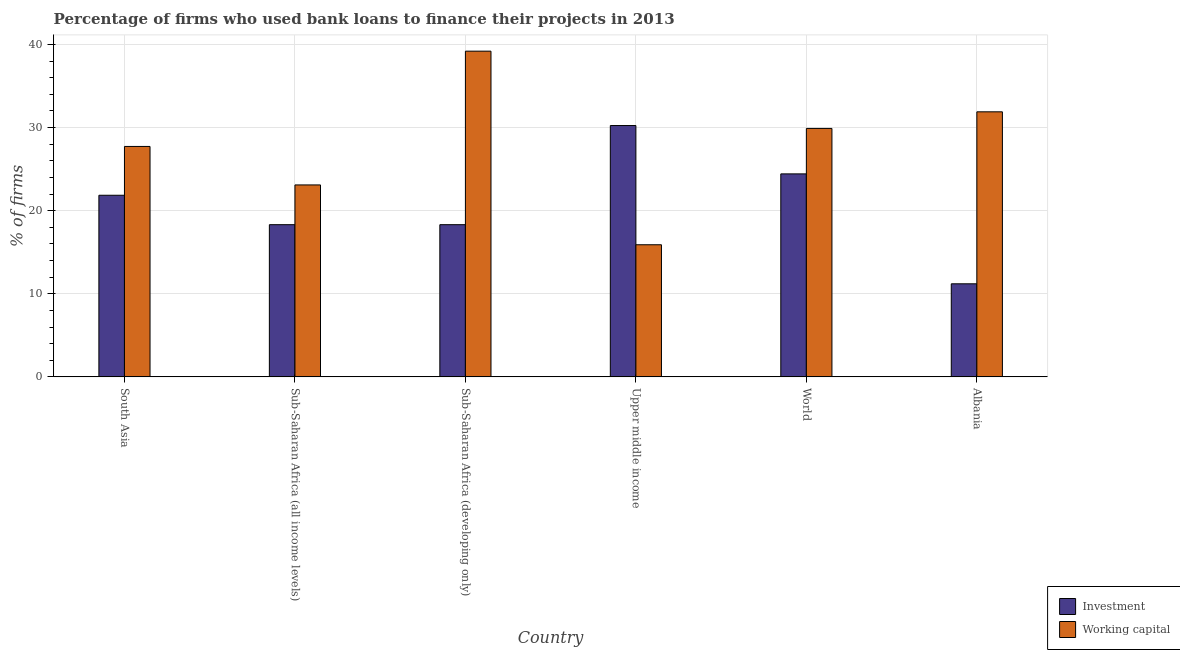Are the number of bars per tick equal to the number of legend labels?
Your answer should be very brief. Yes. Are the number of bars on each tick of the X-axis equal?
Offer a terse response. Yes. How many bars are there on the 6th tick from the left?
Offer a very short reply. 2. How many bars are there on the 2nd tick from the right?
Give a very brief answer. 2. What is the label of the 6th group of bars from the left?
Make the answer very short. Albania. What is the percentage of firms using banks to finance investment in Sub-Saharan Africa (all income levels)?
Offer a terse response. 18.32. Across all countries, what is the maximum percentage of firms using banks to finance working capital?
Provide a short and direct response. 39.2. In which country was the percentage of firms using banks to finance working capital maximum?
Make the answer very short. Sub-Saharan Africa (developing only). In which country was the percentage of firms using banks to finance working capital minimum?
Provide a succinct answer. Upper middle income. What is the total percentage of firms using banks to finance working capital in the graph?
Your answer should be compact. 167.73. What is the difference between the percentage of firms using banks to finance working capital in Albania and that in World?
Give a very brief answer. 2. What is the difference between the percentage of firms using banks to finance working capital in Upper middle income and the percentage of firms using banks to finance investment in World?
Provide a short and direct response. -8.53. What is the average percentage of firms using banks to finance working capital per country?
Your answer should be compact. 27.96. What is the difference between the percentage of firms using banks to finance investment and percentage of firms using banks to finance working capital in Upper middle income?
Your response must be concise. 14.35. What is the ratio of the percentage of firms using banks to finance working capital in Albania to that in Upper middle income?
Your response must be concise. 2.01. Is the difference between the percentage of firms using banks to finance working capital in Sub-Saharan Africa (developing only) and Upper middle income greater than the difference between the percentage of firms using banks to finance investment in Sub-Saharan Africa (developing only) and Upper middle income?
Offer a terse response. Yes. What is the difference between the highest and the second highest percentage of firms using banks to finance working capital?
Ensure brevity in your answer.  7.3. What is the difference between the highest and the lowest percentage of firms using banks to finance working capital?
Keep it short and to the point. 23.3. What does the 1st bar from the left in World represents?
Give a very brief answer. Investment. What does the 1st bar from the right in Sub-Saharan Africa (developing only) represents?
Ensure brevity in your answer.  Working capital. How many bars are there?
Your response must be concise. 12. How many countries are there in the graph?
Give a very brief answer. 6. What is the difference between two consecutive major ticks on the Y-axis?
Offer a terse response. 10. Are the values on the major ticks of Y-axis written in scientific E-notation?
Your answer should be very brief. No. Does the graph contain any zero values?
Offer a terse response. No. Where does the legend appear in the graph?
Offer a terse response. Bottom right. How many legend labels are there?
Keep it short and to the point. 2. How are the legend labels stacked?
Provide a short and direct response. Vertical. What is the title of the graph?
Your answer should be compact. Percentage of firms who used bank loans to finance their projects in 2013. Does "Female labourers" appear as one of the legend labels in the graph?
Offer a very short reply. No. What is the label or title of the X-axis?
Offer a terse response. Country. What is the label or title of the Y-axis?
Your response must be concise. % of firms. What is the % of firms in Investment in South Asia?
Provide a short and direct response. 21.86. What is the % of firms of Working capital in South Asia?
Provide a succinct answer. 27.73. What is the % of firms in Investment in Sub-Saharan Africa (all income levels)?
Provide a succinct answer. 18.32. What is the % of firms in Working capital in Sub-Saharan Africa (all income levels)?
Your answer should be compact. 23.1. What is the % of firms of Investment in Sub-Saharan Africa (developing only)?
Your answer should be very brief. 18.32. What is the % of firms in Working capital in Sub-Saharan Africa (developing only)?
Make the answer very short. 39.2. What is the % of firms of Investment in Upper middle income?
Offer a very short reply. 30.25. What is the % of firms in Working capital in Upper middle income?
Provide a succinct answer. 15.9. What is the % of firms in Investment in World?
Keep it short and to the point. 24.43. What is the % of firms in Working capital in World?
Your answer should be compact. 29.9. What is the % of firms in Working capital in Albania?
Your answer should be compact. 31.9. Across all countries, what is the maximum % of firms of Investment?
Ensure brevity in your answer.  30.25. Across all countries, what is the maximum % of firms of Working capital?
Make the answer very short. 39.2. Across all countries, what is the minimum % of firms of Investment?
Offer a terse response. 11.2. What is the total % of firms of Investment in the graph?
Offer a terse response. 124.37. What is the total % of firms in Working capital in the graph?
Your answer should be very brief. 167.73. What is the difference between the % of firms of Investment in South Asia and that in Sub-Saharan Africa (all income levels)?
Ensure brevity in your answer.  3.54. What is the difference between the % of firms in Working capital in South Asia and that in Sub-Saharan Africa (all income levels)?
Make the answer very short. 4.63. What is the difference between the % of firms of Investment in South Asia and that in Sub-Saharan Africa (developing only)?
Provide a succinct answer. 3.54. What is the difference between the % of firms of Working capital in South Asia and that in Sub-Saharan Africa (developing only)?
Provide a short and direct response. -11.47. What is the difference between the % of firms in Investment in South Asia and that in Upper middle income?
Keep it short and to the point. -8.39. What is the difference between the % of firms in Working capital in South Asia and that in Upper middle income?
Provide a short and direct response. 11.83. What is the difference between the % of firms in Investment in South Asia and that in World?
Offer a terse response. -2.57. What is the difference between the % of firms in Working capital in South Asia and that in World?
Make the answer very short. -2.17. What is the difference between the % of firms in Investment in South Asia and that in Albania?
Give a very brief answer. 10.66. What is the difference between the % of firms in Working capital in South Asia and that in Albania?
Provide a succinct answer. -4.17. What is the difference between the % of firms of Working capital in Sub-Saharan Africa (all income levels) and that in Sub-Saharan Africa (developing only)?
Give a very brief answer. -16.1. What is the difference between the % of firms of Investment in Sub-Saharan Africa (all income levels) and that in Upper middle income?
Give a very brief answer. -11.93. What is the difference between the % of firms in Investment in Sub-Saharan Africa (all income levels) and that in World?
Your answer should be very brief. -6.11. What is the difference between the % of firms in Investment in Sub-Saharan Africa (all income levels) and that in Albania?
Offer a terse response. 7.12. What is the difference between the % of firms of Investment in Sub-Saharan Africa (developing only) and that in Upper middle income?
Offer a terse response. -11.93. What is the difference between the % of firms of Working capital in Sub-Saharan Africa (developing only) and that in Upper middle income?
Provide a short and direct response. 23.3. What is the difference between the % of firms in Investment in Sub-Saharan Africa (developing only) and that in World?
Your answer should be very brief. -6.11. What is the difference between the % of firms of Working capital in Sub-Saharan Africa (developing only) and that in World?
Give a very brief answer. 9.3. What is the difference between the % of firms of Investment in Sub-Saharan Africa (developing only) and that in Albania?
Ensure brevity in your answer.  7.12. What is the difference between the % of firms in Working capital in Sub-Saharan Africa (developing only) and that in Albania?
Your response must be concise. 7.3. What is the difference between the % of firms of Investment in Upper middle income and that in World?
Offer a terse response. 5.82. What is the difference between the % of firms in Working capital in Upper middle income and that in World?
Give a very brief answer. -14. What is the difference between the % of firms of Investment in Upper middle income and that in Albania?
Give a very brief answer. 19.05. What is the difference between the % of firms of Working capital in Upper middle income and that in Albania?
Your response must be concise. -16. What is the difference between the % of firms in Investment in World and that in Albania?
Keep it short and to the point. 13.23. What is the difference between the % of firms of Investment in South Asia and the % of firms of Working capital in Sub-Saharan Africa (all income levels)?
Your response must be concise. -1.24. What is the difference between the % of firms in Investment in South Asia and the % of firms in Working capital in Sub-Saharan Africa (developing only)?
Offer a terse response. -17.34. What is the difference between the % of firms of Investment in South Asia and the % of firms of Working capital in Upper middle income?
Your response must be concise. 5.96. What is the difference between the % of firms in Investment in South Asia and the % of firms in Working capital in World?
Offer a terse response. -8.04. What is the difference between the % of firms of Investment in South Asia and the % of firms of Working capital in Albania?
Your response must be concise. -10.04. What is the difference between the % of firms in Investment in Sub-Saharan Africa (all income levels) and the % of firms in Working capital in Sub-Saharan Africa (developing only)?
Offer a terse response. -20.88. What is the difference between the % of firms of Investment in Sub-Saharan Africa (all income levels) and the % of firms of Working capital in Upper middle income?
Offer a terse response. 2.42. What is the difference between the % of firms in Investment in Sub-Saharan Africa (all income levels) and the % of firms in Working capital in World?
Your answer should be very brief. -11.58. What is the difference between the % of firms in Investment in Sub-Saharan Africa (all income levels) and the % of firms in Working capital in Albania?
Give a very brief answer. -13.58. What is the difference between the % of firms of Investment in Sub-Saharan Africa (developing only) and the % of firms of Working capital in Upper middle income?
Ensure brevity in your answer.  2.42. What is the difference between the % of firms of Investment in Sub-Saharan Africa (developing only) and the % of firms of Working capital in World?
Your response must be concise. -11.58. What is the difference between the % of firms of Investment in Sub-Saharan Africa (developing only) and the % of firms of Working capital in Albania?
Ensure brevity in your answer.  -13.58. What is the difference between the % of firms in Investment in Upper middle income and the % of firms in Working capital in World?
Offer a very short reply. 0.35. What is the difference between the % of firms in Investment in Upper middle income and the % of firms in Working capital in Albania?
Your answer should be very brief. -1.65. What is the difference between the % of firms in Investment in World and the % of firms in Working capital in Albania?
Keep it short and to the point. -7.47. What is the average % of firms of Investment per country?
Make the answer very short. 20.73. What is the average % of firms of Working capital per country?
Give a very brief answer. 27.96. What is the difference between the % of firms of Investment and % of firms of Working capital in South Asia?
Keep it short and to the point. -5.87. What is the difference between the % of firms in Investment and % of firms in Working capital in Sub-Saharan Africa (all income levels)?
Ensure brevity in your answer.  -4.78. What is the difference between the % of firms in Investment and % of firms in Working capital in Sub-Saharan Africa (developing only)?
Give a very brief answer. -20.88. What is the difference between the % of firms of Investment and % of firms of Working capital in Upper middle income?
Your answer should be very brief. 14.35. What is the difference between the % of firms of Investment and % of firms of Working capital in World?
Your answer should be very brief. -5.47. What is the difference between the % of firms of Investment and % of firms of Working capital in Albania?
Your response must be concise. -20.7. What is the ratio of the % of firms in Investment in South Asia to that in Sub-Saharan Africa (all income levels)?
Provide a short and direct response. 1.19. What is the ratio of the % of firms of Working capital in South Asia to that in Sub-Saharan Africa (all income levels)?
Ensure brevity in your answer.  1.2. What is the ratio of the % of firms of Investment in South Asia to that in Sub-Saharan Africa (developing only)?
Give a very brief answer. 1.19. What is the ratio of the % of firms of Working capital in South Asia to that in Sub-Saharan Africa (developing only)?
Keep it short and to the point. 0.71. What is the ratio of the % of firms of Investment in South Asia to that in Upper middle income?
Provide a succinct answer. 0.72. What is the ratio of the % of firms of Working capital in South Asia to that in Upper middle income?
Provide a succinct answer. 1.74. What is the ratio of the % of firms of Investment in South Asia to that in World?
Give a very brief answer. 0.89. What is the ratio of the % of firms of Working capital in South Asia to that in World?
Provide a succinct answer. 0.93. What is the ratio of the % of firms in Investment in South Asia to that in Albania?
Give a very brief answer. 1.95. What is the ratio of the % of firms of Working capital in South Asia to that in Albania?
Make the answer very short. 0.87. What is the ratio of the % of firms in Working capital in Sub-Saharan Africa (all income levels) to that in Sub-Saharan Africa (developing only)?
Provide a short and direct response. 0.59. What is the ratio of the % of firms of Investment in Sub-Saharan Africa (all income levels) to that in Upper middle income?
Your answer should be compact. 0.61. What is the ratio of the % of firms of Working capital in Sub-Saharan Africa (all income levels) to that in Upper middle income?
Make the answer very short. 1.45. What is the ratio of the % of firms in Investment in Sub-Saharan Africa (all income levels) to that in World?
Give a very brief answer. 0.75. What is the ratio of the % of firms of Working capital in Sub-Saharan Africa (all income levels) to that in World?
Give a very brief answer. 0.77. What is the ratio of the % of firms of Investment in Sub-Saharan Africa (all income levels) to that in Albania?
Offer a very short reply. 1.64. What is the ratio of the % of firms of Working capital in Sub-Saharan Africa (all income levels) to that in Albania?
Your answer should be very brief. 0.72. What is the ratio of the % of firms of Investment in Sub-Saharan Africa (developing only) to that in Upper middle income?
Ensure brevity in your answer.  0.61. What is the ratio of the % of firms in Working capital in Sub-Saharan Africa (developing only) to that in Upper middle income?
Give a very brief answer. 2.47. What is the ratio of the % of firms in Investment in Sub-Saharan Africa (developing only) to that in World?
Make the answer very short. 0.75. What is the ratio of the % of firms of Working capital in Sub-Saharan Africa (developing only) to that in World?
Your answer should be very brief. 1.31. What is the ratio of the % of firms of Investment in Sub-Saharan Africa (developing only) to that in Albania?
Offer a very short reply. 1.64. What is the ratio of the % of firms in Working capital in Sub-Saharan Africa (developing only) to that in Albania?
Your response must be concise. 1.23. What is the ratio of the % of firms in Investment in Upper middle income to that in World?
Your response must be concise. 1.24. What is the ratio of the % of firms of Working capital in Upper middle income to that in World?
Keep it short and to the point. 0.53. What is the ratio of the % of firms of Investment in Upper middle income to that in Albania?
Give a very brief answer. 2.7. What is the ratio of the % of firms of Working capital in Upper middle income to that in Albania?
Keep it short and to the point. 0.5. What is the ratio of the % of firms of Investment in World to that in Albania?
Offer a very short reply. 2.18. What is the ratio of the % of firms in Working capital in World to that in Albania?
Offer a very short reply. 0.94. What is the difference between the highest and the second highest % of firms in Investment?
Your answer should be very brief. 5.82. What is the difference between the highest and the lowest % of firms of Investment?
Offer a very short reply. 19.05. What is the difference between the highest and the lowest % of firms in Working capital?
Give a very brief answer. 23.3. 